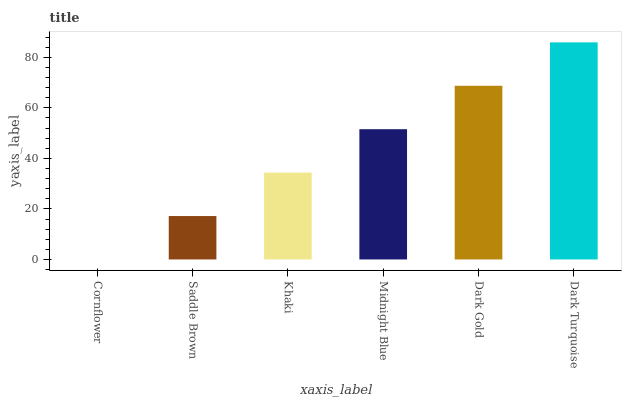Is Cornflower the minimum?
Answer yes or no. Yes. Is Dark Turquoise the maximum?
Answer yes or no. Yes. Is Saddle Brown the minimum?
Answer yes or no. No. Is Saddle Brown the maximum?
Answer yes or no. No. Is Saddle Brown greater than Cornflower?
Answer yes or no. Yes. Is Cornflower less than Saddle Brown?
Answer yes or no. Yes. Is Cornflower greater than Saddle Brown?
Answer yes or no. No. Is Saddle Brown less than Cornflower?
Answer yes or no. No. Is Midnight Blue the high median?
Answer yes or no. Yes. Is Khaki the low median?
Answer yes or no. Yes. Is Khaki the high median?
Answer yes or no. No. Is Midnight Blue the low median?
Answer yes or no. No. 